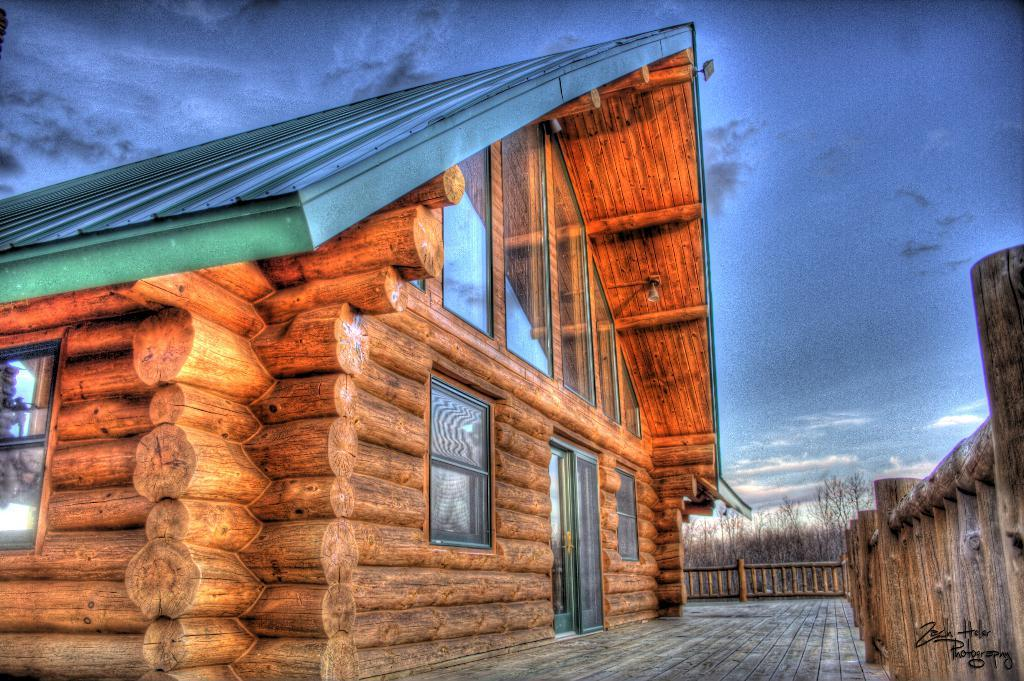What material is the house in the image made of? The house in the image is made of wood. What can be seen inside the house? There are glasses visible inside the house. What is visible on the right side of the image? The sky is visible on the right side of the image. What chess move is the achiever making on their journey in the image? There is no chess, achiever, or journey present in the image. 